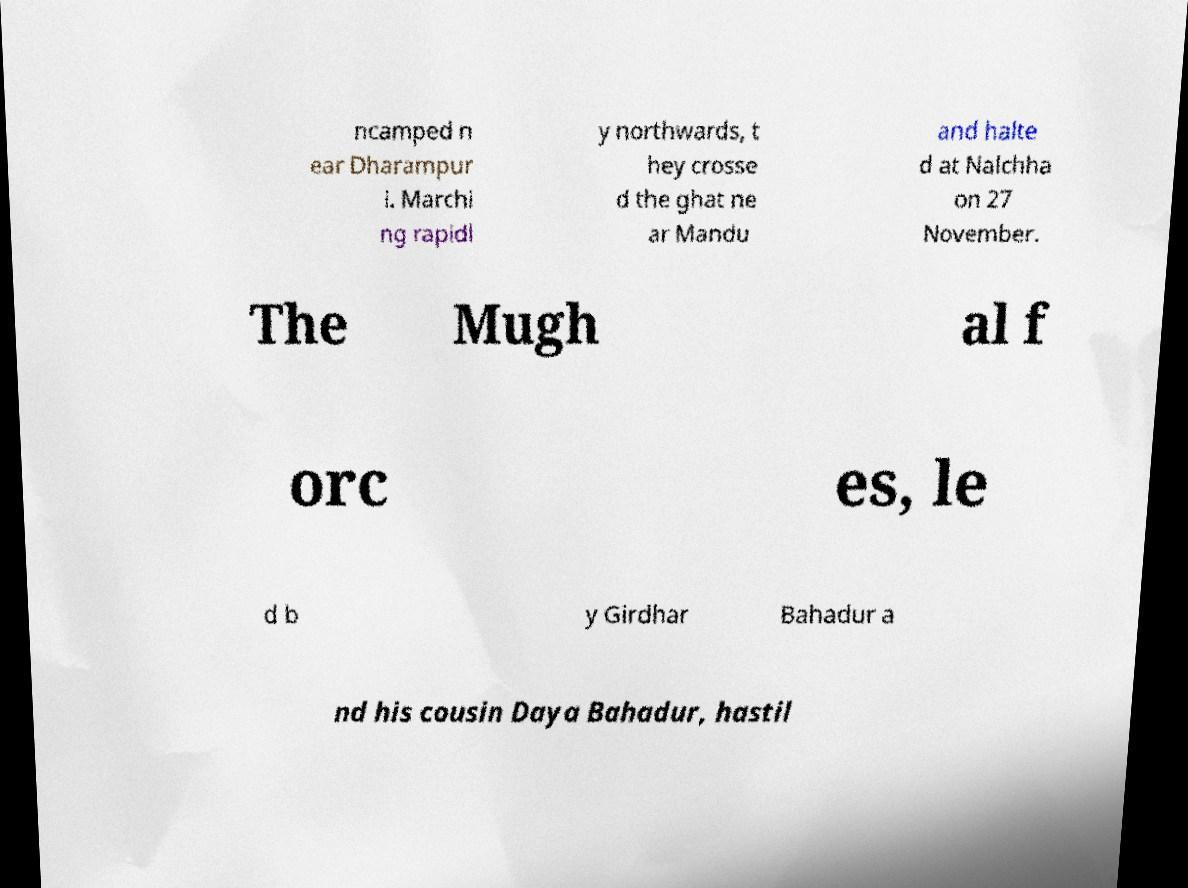There's text embedded in this image that I need extracted. Can you transcribe it verbatim? ncamped n ear Dharampur i. Marchi ng rapidl y northwards, t hey crosse d the ghat ne ar Mandu and halte d at Nalchha on 27 November. The Mugh al f orc es, le d b y Girdhar Bahadur a nd his cousin Daya Bahadur, hastil 